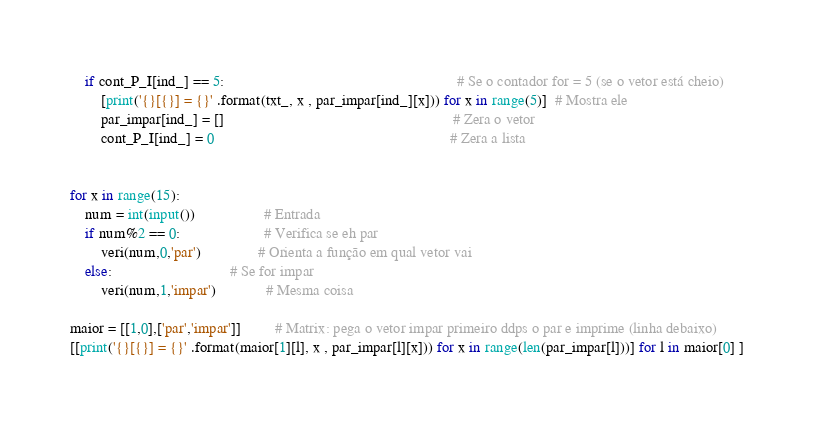<code> <loc_0><loc_0><loc_500><loc_500><_Python_>    if cont_P_I[ind_] == 5:                                                             # Se o contador for = 5 (se o vetor está cheio)
        [print('{}[{}] = {}' .format(txt_, x , par_impar[ind_][x])) for x in range(5)]  # Mostra ele
        par_impar[ind_] = []                                                            # Zera o vetor
        cont_P_I[ind_] = 0                                                              # Zera a lista


for x in range(15):
    num = int(input())                  # Entrada             
    if num%2 == 0:                      # Verifica se eh par
        veri(num,0,'par')               # Orienta a função em qual vetor vai     
    else:                               # Se for impar
        veri(num,1,'impar')             # Mesma coisa

maior = [[1,0],['par','impar']]         # Matrix: pega o vetor impar primeiro ddps o par e imprime (linha debaixo)
[[print('{}[{}] = {}' .format(maior[1][l], x , par_impar[l][x])) for x in range(len(par_impar[l]))] for l in maior[0] ]</code> 